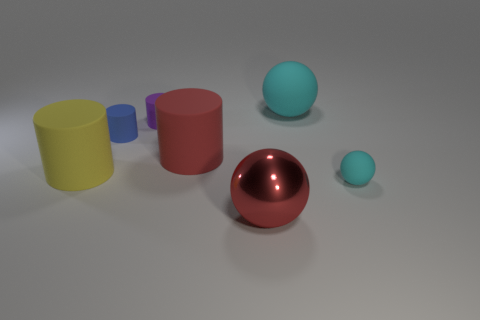How many things are either matte cylinders in front of the purple cylinder or large balls that are in front of the tiny rubber ball?
Provide a short and direct response. 4. There is a red object that is left of the shiny object; is its size the same as the small purple cylinder?
Your answer should be very brief. No. What color is the large rubber ball on the right side of the large yellow object?
Give a very brief answer. Cyan. There is another tiny object that is the same shape as the purple rubber object; what color is it?
Your answer should be compact. Blue. There is a cyan thing that is on the right side of the cyan rubber ball that is behind the large yellow thing; how many things are behind it?
Your response must be concise. 5. Is there any other thing that is made of the same material as the small blue thing?
Keep it short and to the point. Yes. Is the number of cyan spheres that are right of the tiny matte sphere less than the number of cyan matte things?
Make the answer very short. Yes. Do the small sphere and the big shiny thing have the same color?
Keep it short and to the point. No. There is a yellow thing that is the same shape as the small purple matte thing; what is its size?
Offer a very short reply. Large. How many yellow cylinders have the same material as the large yellow object?
Ensure brevity in your answer.  0. 